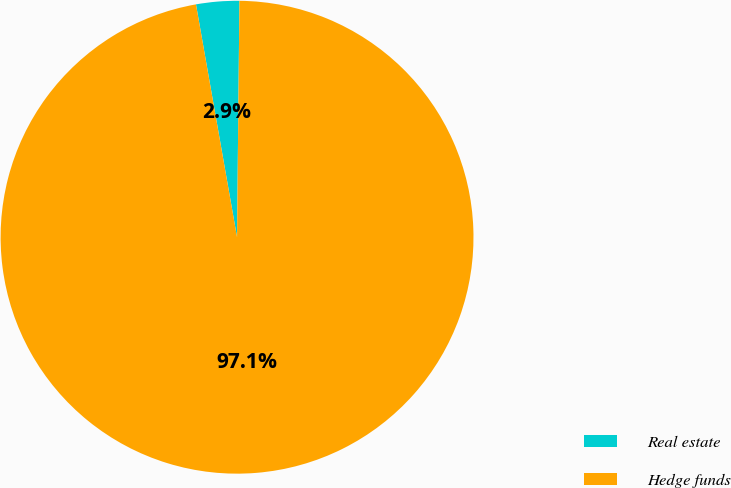Convert chart. <chart><loc_0><loc_0><loc_500><loc_500><pie_chart><fcel>Real estate<fcel>Hedge funds<nl><fcel>2.94%<fcel>97.06%<nl></chart> 